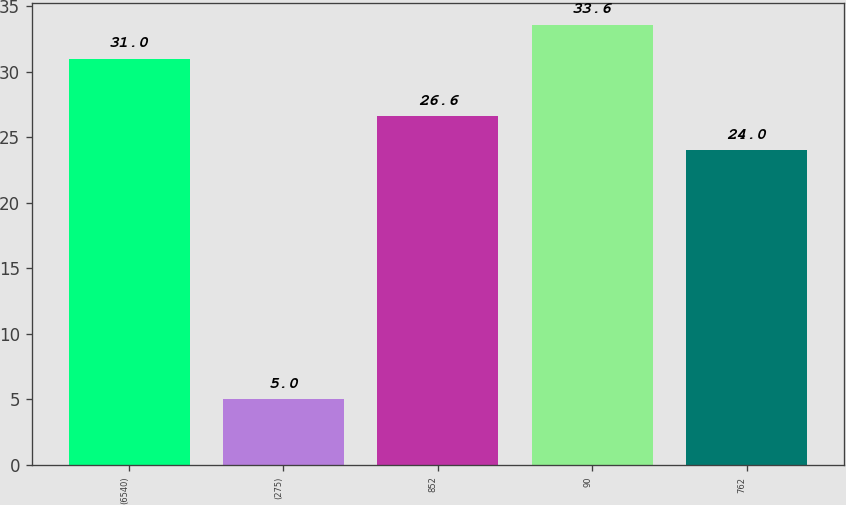Convert chart. <chart><loc_0><loc_0><loc_500><loc_500><bar_chart><fcel>(6540)<fcel>(275)<fcel>852<fcel>90<fcel>762<nl><fcel>31<fcel>5<fcel>26.6<fcel>33.6<fcel>24<nl></chart> 